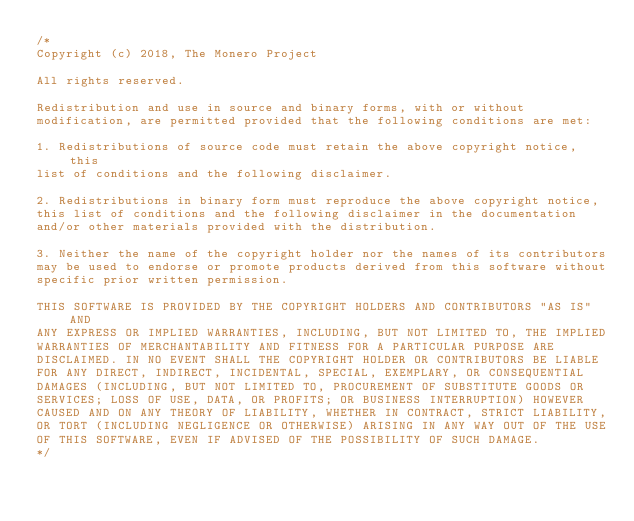Convert code to text. <code><loc_0><loc_0><loc_500><loc_500><_C_>/*
Copyright (c) 2018, The Monero Project

All rights reserved.

Redistribution and use in source and binary forms, with or without
modification, are permitted provided that the following conditions are met:

1. Redistributions of source code must retain the above copyright notice, this
list of conditions and the following disclaimer.

2. Redistributions in binary form must reproduce the above copyright notice,
this list of conditions and the following disclaimer in the documentation
and/or other materials provided with the distribution.

3. Neither the name of the copyright holder nor the names of its contributors
may be used to endorse or promote products derived from this software without
specific prior written permission.

THIS SOFTWARE IS PROVIDED BY THE COPYRIGHT HOLDERS AND CONTRIBUTORS "AS IS" AND
ANY EXPRESS OR IMPLIED WARRANTIES, INCLUDING, BUT NOT LIMITED TO, THE IMPLIED
WARRANTIES OF MERCHANTABILITY AND FITNESS FOR A PARTICULAR PURPOSE ARE
DISCLAIMED. IN NO EVENT SHALL THE COPYRIGHT HOLDER OR CONTRIBUTORS BE LIABLE
FOR ANY DIRECT, INDIRECT, INCIDENTAL, SPECIAL, EXEMPLARY, OR CONSEQUENTIAL
DAMAGES (INCLUDING, BUT NOT LIMITED TO, PROCUREMENT OF SUBSTITUTE GOODS OR
SERVICES; LOSS OF USE, DATA, OR PROFITS; OR BUSINESS INTERRUPTION) HOWEVER
CAUSED AND ON ANY THEORY OF LIABILITY, WHETHER IN CONTRACT, STRICT LIABILITY,
OR TORT (INCLUDING NEGLIGENCE OR OTHERWISE) ARISING IN ANY WAY OUT OF THE USE
OF THIS SOFTWARE, EVEN IF ADVISED OF THE POSSIBILITY OF SUCH DAMAGE.
*/
</code> 